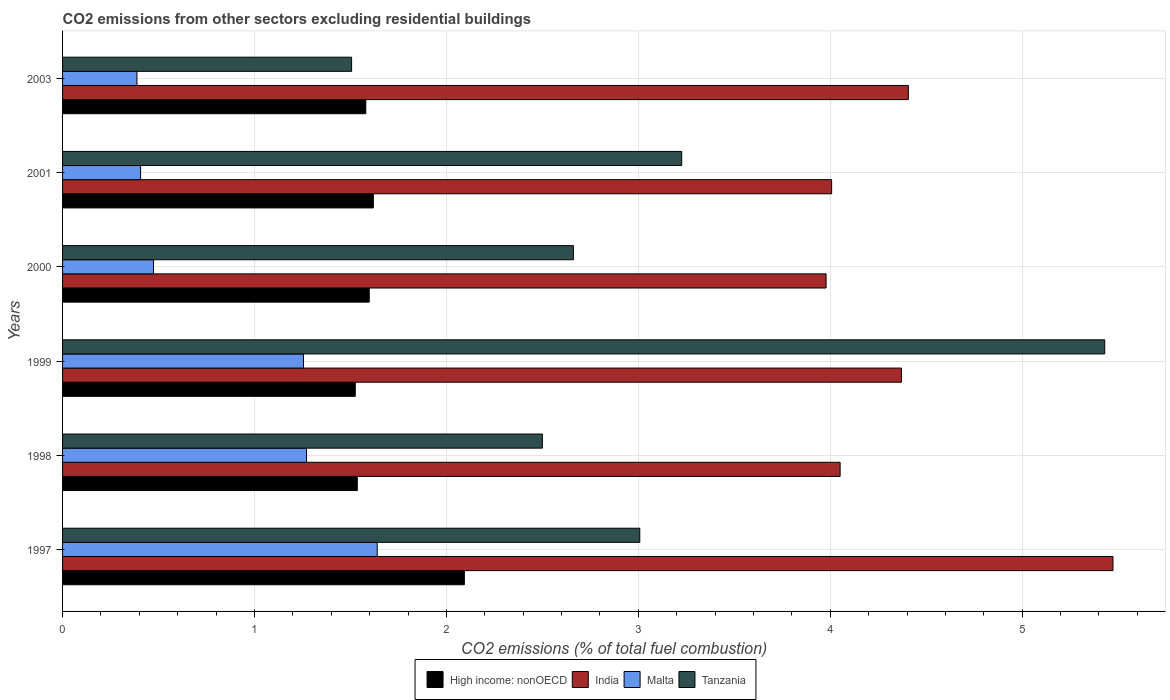How many bars are there on the 5th tick from the top?
Your answer should be very brief. 4. What is the label of the 1st group of bars from the top?
Provide a short and direct response. 2003. What is the total CO2 emitted in Tanzania in 2003?
Ensure brevity in your answer.  1.51. Across all years, what is the maximum total CO2 emitted in India?
Ensure brevity in your answer.  5.47. Across all years, what is the minimum total CO2 emitted in Malta?
Ensure brevity in your answer.  0.39. What is the total total CO2 emitted in India in the graph?
Offer a very short reply. 26.29. What is the difference between the total CO2 emitted in High income: nonOECD in 1997 and that in 2000?
Keep it short and to the point. 0.5. What is the difference between the total CO2 emitted in High income: nonOECD in 1999 and the total CO2 emitted in Tanzania in 2003?
Your response must be concise. 0.02. What is the average total CO2 emitted in India per year?
Keep it short and to the point. 4.38. In the year 1998, what is the difference between the total CO2 emitted in Malta and total CO2 emitted in India?
Provide a short and direct response. -2.78. In how many years, is the total CO2 emitted in High income: nonOECD greater than 3.4 ?
Make the answer very short. 0. What is the ratio of the total CO2 emitted in High income: nonOECD in 2000 to that in 2001?
Your answer should be compact. 0.99. Is the total CO2 emitted in Malta in 2001 less than that in 2003?
Offer a terse response. No. Is the difference between the total CO2 emitted in Malta in 2000 and 2001 greater than the difference between the total CO2 emitted in India in 2000 and 2001?
Provide a succinct answer. Yes. What is the difference between the highest and the second highest total CO2 emitted in Malta?
Keep it short and to the point. 0.37. What is the difference between the highest and the lowest total CO2 emitted in India?
Provide a succinct answer. 1.49. In how many years, is the total CO2 emitted in High income: nonOECD greater than the average total CO2 emitted in High income: nonOECD taken over all years?
Provide a short and direct response. 1. Is the sum of the total CO2 emitted in India in 1997 and 2003 greater than the maximum total CO2 emitted in Tanzania across all years?
Give a very brief answer. Yes. Is it the case that in every year, the sum of the total CO2 emitted in Malta and total CO2 emitted in High income: nonOECD is greater than the sum of total CO2 emitted in India and total CO2 emitted in Tanzania?
Your answer should be compact. No. What does the 4th bar from the top in 2003 represents?
Provide a short and direct response. High income: nonOECD. What does the 3rd bar from the bottom in 2003 represents?
Your response must be concise. Malta. Are all the bars in the graph horizontal?
Provide a short and direct response. Yes. How many years are there in the graph?
Give a very brief answer. 6. What is the difference between two consecutive major ticks on the X-axis?
Your answer should be very brief. 1. Are the values on the major ticks of X-axis written in scientific E-notation?
Ensure brevity in your answer.  No. Does the graph contain any zero values?
Give a very brief answer. No. How many legend labels are there?
Make the answer very short. 4. How are the legend labels stacked?
Your answer should be very brief. Horizontal. What is the title of the graph?
Your answer should be very brief. CO2 emissions from other sectors excluding residential buildings. What is the label or title of the X-axis?
Keep it short and to the point. CO2 emissions (% of total fuel combustion). What is the label or title of the Y-axis?
Your answer should be compact. Years. What is the CO2 emissions (% of total fuel combustion) of High income: nonOECD in 1997?
Keep it short and to the point. 2.09. What is the CO2 emissions (% of total fuel combustion) in India in 1997?
Ensure brevity in your answer.  5.47. What is the CO2 emissions (% of total fuel combustion) in Malta in 1997?
Make the answer very short. 1.64. What is the CO2 emissions (% of total fuel combustion) in Tanzania in 1997?
Your answer should be very brief. 3.01. What is the CO2 emissions (% of total fuel combustion) in High income: nonOECD in 1998?
Your response must be concise. 1.54. What is the CO2 emissions (% of total fuel combustion) of India in 1998?
Give a very brief answer. 4.05. What is the CO2 emissions (% of total fuel combustion) of Malta in 1998?
Ensure brevity in your answer.  1.27. What is the CO2 emissions (% of total fuel combustion) of High income: nonOECD in 1999?
Give a very brief answer. 1.53. What is the CO2 emissions (% of total fuel combustion) in India in 1999?
Keep it short and to the point. 4.37. What is the CO2 emissions (% of total fuel combustion) in Malta in 1999?
Keep it short and to the point. 1.26. What is the CO2 emissions (% of total fuel combustion) in Tanzania in 1999?
Offer a terse response. 5.43. What is the CO2 emissions (% of total fuel combustion) in High income: nonOECD in 2000?
Provide a short and direct response. 1.6. What is the CO2 emissions (% of total fuel combustion) of India in 2000?
Make the answer very short. 3.98. What is the CO2 emissions (% of total fuel combustion) of Malta in 2000?
Give a very brief answer. 0.47. What is the CO2 emissions (% of total fuel combustion) of Tanzania in 2000?
Provide a short and direct response. 2.66. What is the CO2 emissions (% of total fuel combustion) of High income: nonOECD in 2001?
Your answer should be very brief. 1.62. What is the CO2 emissions (% of total fuel combustion) of India in 2001?
Offer a terse response. 4.01. What is the CO2 emissions (% of total fuel combustion) of Malta in 2001?
Provide a succinct answer. 0.41. What is the CO2 emissions (% of total fuel combustion) in Tanzania in 2001?
Your answer should be very brief. 3.23. What is the CO2 emissions (% of total fuel combustion) in High income: nonOECD in 2003?
Offer a terse response. 1.58. What is the CO2 emissions (% of total fuel combustion) of India in 2003?
Give a very brief answer. 4.41. What is the CO2 emissions (% of total fuel combustion) in Malta in 2003?
Provide a succinct answer. 0.39. What is the CO2 emissions (% of total fuel combustion) of Tanzania in 2003?
Provide a succinct answer. 1.51. Across all years, what is the maximum CO2 emissions (% of total fuel combustion) in High income: nonOECD?
Your answer should be very brief. 2.09. Across all years, what is the maximum CO2 emissions (% of total fuel combustion) in India?
Provide a short and direct response. 5.47. Across all years, what is the maximum CO2 emissions (% of total fuel combustion) of Malta?
Keep it short and to the point. 1.64. Across all years, what is the maximum CO2 emissions (% of total fuel combustion) of Tanzania?
Keep it short and to the point. 5.43. Across all years, what is the minimum CO2 emissions (% of total fuel combustion) of High income: nonOECD?
Your response must be concise. 1.53. Across all years, what is the minimum CO2 emissions (% of total fuel combustion) in India?
Your answer should be compact. 3.98. Across all years, what is the minimum CO2 emissions (% of total fuel combustion) of Malta?
Your answer should be very brief. 0.39. Across all years, what is the minimum CO2 emissions (% of total fuel combustion) of Tanzania?
Provide a short and direct response. 1.51. What is the total CO2 emissions (% of total fuel combustion) of High income: nonOECD in the graph?
Your response must be concise. 9.95. What is the total CO2 emissions (% of total fuel combustion) in India in the graph?
Your answer should be very brief. 26.29. What is the total CO2 emissions (% of total fuel combustion) in Malta in the graph?
Provide a succinct answer. 5.43. What is the total CO2 emissions (% of total fuel combustion) of Tanzania in the graph?
Provide a succinct answer. 18.33. What is the difference between the CO2 emissions (% of total fuel combustion) in High income: nonOECD in 1997 and that in 1998?
Give a very brief answer. 0.56. What is the difference between the CO2 emissions (% of total fuel combustion) of India in 1997 and that in 1998?
Your answer should be compact. 1.42. What is the difference between the CO2 emissions (% of total fuel combustion) in Malta in 1997 and that in 1998?
Offer a terse response. 0.37. What is the difference between the CO2 emissions (% of total fuel combustion) of Tanzania in 1997 and that in 1998?
Your answer should be compact. 0.51. What is the difference between the CO2 emissions (% of total fuel combustion) of High income: nonOECD in 1997 and that in 1999?
Provide a succinct answer. 0.57. What is the difference between the CO2 emissions (% of total fuel combustion) in India in 1997 and that in 1999?
Make the answer very short. 1.1. What is the difference between the CO2 emissions (% of total fuel combustion) of Malta in 1997 and that in 1999?
Keep it short and to the point. 0.38. What is the difference between the CO2 emissions (% of total fuel combustion) in Tanzania in 1997 and that in 1999?
Keep it short and to the point. -2.42. What is the difference between the CO2 emissions (% of total fuel combustion) in High income: nonOECD in 1997 and that in 2000?
Keep it short and to the point. 0.5. What is the difference between the CO2 emissions (% of total fuel combustion) in India in 1997 and that in 2000?
Ensure brevity in your answer.  1.49. What is the difference between the CO2 emissions (% of total fuel combustion) of Malta in 1997 and that in 2000?
Ensure brevity in your answer.  1.17. What is the difference between the CO2 emissions (% of total fuel combustion) in Tanzania in 1997 and that in 2000?
Your answer should be compact. 0.35. What is the difference between the CO2 emissions (% of total fuel combustion) of High income: nonOECD in 1997 and that in 2001?
Your response must be concise. 0.47. What is the difference between the CO2 emissions (% of total fuel combustion) of India in 1997 and that in 2001?
Give a very brief answer. 1.47. What is the difference between the CO2 emissions (% of total fuel combustion) in Malta in 1997 and that in 2001?
Offer a terse response. 1.23. What is the difference between the CO2 emissions (% of total fuel combustion) of Tanzania in 1997 and that in 2001?
Offer a very short reply. -0.22. What is the difference between the CO2 emissions (% of total fuel combustion) in High income: nonOECD in 1997 and that in 2003?
Provide a short and direct response. 0.51. What is the difference between the CO2 emissions (% of total fuel combustion) of India in 1997 and that in 2003?
Keep it short and to the point. 1.07. What is the difference between the CO2 emissions (% of total fuel combustion) in Malta in 1997 and that in 2003?
Your answer should be compact. 1.25. What is the difference between the CO2 emissions (% of total fuel combustion) in Tanzania in 1997 and that in 2003?
Your response must be concise. 1.5. What is the difference between the CO2 emissions (% of total fuel combustion) of High income: nonOECD in 1998 and that in 1999?
Your response must be concise. 0.01. What is the difference between the CO2 emissions (% of total fuel combustion) in India in 1998 and that in 1999?
Your response must be concise. -0.32. What is the difference between the CO2 emissions (% of total fuel combustion) in Malta in 1998 and that in 1999?
Your answer should be very brief. 0.02. What is the difference between the CO2 emissions (% of total fuel combustion) in Tanzania in 1998 and that in 1999?
Keep it short and to the point. -2.93. What is the difference between the CO2 emissions (% of total fuel combustion) in High income: nonOECD in 1998 and that in 2000?
Provide a short and direct response. -0.06. What is the difference between the CO2 emissions (% of total fuel combustion) of India in 1998 and that in 2000?
Provide a succinct answer. 0.07. What is the difference between the CO2 emissions (% of total fuel combustion) in Malta in 1998 and that in 2000?
Your response must be concise. 0.8. What is the difference between the CO2 emissions (% of total fuel combustion) in Tanzania in 1998 and that in 2000?
Your response must be concise. -0.16. What is the difference between the CO2 emissions (% of total fuel combustion) of High income: nonOECD in 1998 and that in 2001?
Ensure brevity in your answer.  -0.08. What is the difference between the CO2 emissions (% of total fuel combustion) of India in 1998 and that in 2001?
Provide a short and direct response. 0.04. What is the difference between the CO2 emissions (% of total fuel combustion) of Malta in 1998 and that in 2001?
Give a very brief answer. 0.86. What is the difference between the CO2 emissions (% of total fuel combustion) of Tanzania in 1998 and that in 2001?
Keep it short and to the point. -0.73. What is the difference between the CO2 emissions (% of total fuel combustion) of High income: nonOECD in 1998 and that in 2003?
Offer a very short reply. -0.04. What is the difference between the CO2 emissions (% of total fuel combustion) in India in 1998 and that in 2003?
Provide a succinct answer. -0.36. What is the difference between the CO2 emissions (% of total fuel combustion) of Malta in 1998 and that in 2003?
Your response must be concise. 0.88. What is the difference between the CO2 emissions (% of total fuel combustion) of Tanzania in 1998 and that in 2003?
Offer a very short reply. 0.99. What is the difference between the CO2 emissions (% of total fuel combustion) in High income: nonOECD in 1999 and that in 2000?
Ensure brevity in your answer.  -0.07. What is the difference between the CO2 emissions (% of total fuel combustion) in India in 1999 and that in 2000?
Your response must be concise. 0.39. What is the difference between the CO2 emissions (% of total fuel combustion) of Malta in 1999 and that in 2000?
Ensure brevity in your answer.  0.78. What is the difference between the CO2 emissions (% of total fuel combustion) in Tanzania in 1999 and that in 2000?
Offer a terse response. 2.77. What is the difference between the CO2 emissions (% of total fuel combustion) in High income: nonOECD in 1999 and that in 2001?
Offer a very short reply. -0.09. What is the difference between the CO2 emissions (% of total fuel combustion) in India in 1999 and that in 2001?
Provide a short and direct response. 0.36. What is the difference between the CO2 emissions (% of total fuel combustion) in Malta in 1999 and that in 2001?
Keep it short and to the point. 0.85. What is the difference between the CO2 emissions (% of total fuel combustion) in Tanzania in 1999 and that in 2001?
Offer a very short reply. 2.2. What is the difference between the CO2 emissions (% of total fuel combustion) in High income: nonOECD in 1999 and that in 2003?
Give a very brief answer. -0.05. What is the difference between the CO2 emissions (% of total fuel combustion) in India in 1999 and that in 2003?
Keep it short and to the point. -0.04. What is the difference between the CO2 emissions (% of total fuel combustion) in Malta in 1999 and that in 2003?
Provide a succinct answer. 0.87. What is the difference between the CO2 emissions (% of total fuel combustion) in Tanzania in 1999 and that in 2003?
Your answer should be compact. 3.92. What is the difference between the CO2 emissions (% of total fuel combustion) of High income: nonOECD in 2000 and that in 2001?
Provide a succinct answer. -0.02. What is the difference between the CO2 emissions (% of total fuel combustion) in India in 2000 and that in 2001?
Provide a short and direct response. -0.03. What is the difference between the CO2 emissions (% of total fuel combustion) in Malta in 2000 and that in 2001?
Your answer should be very brief. 0.07. What is the difference between the CO2 emissions (% of total fuel combustion) of Tanzania in 2000 and that in 2001?
Ensure brevity in your answer.  -0.56. What is the difference between the CO2 emissions (% of total fuel combustion) in High income: nonOECD in 2000 and that in 2003?
Ensure brevity in your answer.  0.02. What is the difference between the CO2 emissions (% of total fuel combustion) in India in 2000 and that in 2003?
Offer a terse response. -0.43. What is the difference between the CO2 emissions (% of total fuel combustion) of Malta in 2000 and that in 2003?
Offer a terse response. 0.09. What is the difference between the CO2 emissions (% of total fuel combustion) in Tanzania in 2000 and that in 2003?
Make the answer very short. 1.16. What is the difference between the CO2 emissions (% of total fuel combustion) of High income: nonOECD in 2001 and that in 2003?
Provide a succinct answer. 0.04. What is the difference between the CO2 emissions (% of total fuel combustion) in India in 2001 and that in 2003?
Provide a succinct answer. -0.4. What is the difference between the CO2 emissions (% of total fuel combustion) in Malta in 2001 and that in 2003?
Ensure brevity in your answer.  0.02. What is the difference between the CO2 emissions (% of total fuel combustion) in Tanzania in 2001 and that in 2003?
Your answer should be very brief. 1.72. What is the difference between the CO2 emissions (% of total fuel combustion) in High income: nonOECD in 1997 and the CO2 emissions (% of total fuel combustion) in India in 1998?
Offer a very short reply. -1.96. What is the difference between the CO2 emissions (% of total fuel combustion) of High income: nonOECD in 1997 and the CO2 emissions (% of total fuel combustion) of Malta in 1998?
Your answer should be very brief. 0.82. What is the difference between the CO2 emissions (% of total fuel combustion) of High income: nonOECD in 1997 and the CO2 emissions (% of total fuel combustion) of Tanzania in 1998?
Offer a very short reply. -0.41. What is the difference between the CO2 emissions (% of total fuel combustion) in India in 1997 and the CO2 emissions (% of total fuel combustion) in Malta in 1998?
Offer a very short reply. 4.2. What is the difference between the CO2 emissions (% of total fuel combustion) of India in 1997 and the CO2 emissions (% of total fuel combustion) of Tanzania in 1998?
Offer a terse response. 2.97. What is the difference between the CO2 emissions (% of total fuel combustion) of Malta in 1997 and the CO2 emissions (% of total fuel combustion) of Tanzania in 1998?
Offer a terse response. -0.86. What is the difference between the CO2 emissions (% of total fuel combustion) in High income: nonOECD in 1997 and the CO2 emissions (% of total fuel combustion) in India in 1999?
Ensure brevity in your answer.  -2.28. What is the difference between the CO2 emissions (% of total fuel combustion) in High income: nonOECD in 1997 and the CO2 emissions (% of total fuel combustion) in Malta in 1999?
Give a very brief answer. 0.84. What is the difference between the CO2 emissions (% of total fuel combustion) of High income: nonOECD in 1997 and the CO2 emissions (% of total fuel combustion) of Tanzania in 1999?
Your answer should be very brief. -3.34. What is the difference between the CO2 emissions (% of total fuel combustion) in India in 1997 and the CO2 emissions (% of total fuel combustion) in Malta in 1999?
Keep it short and to the point. 4.22. What is the difference between the CO2 emissions (% of total fuel combustion) of India in 1997 and the CO2 emissions (% of total fuel combustion) of Tanzania in 1999?
Keep it short and to the point. 0.04. What is the difference between the CO2 emissions (% of total fuel combustion) of Malta in 1997 and the CO2 emissions (% of total fuel combustion) of Tanzania in 1999?
Keep it short and to the point. -3.79. What is the difference between the CO2 emissions (% of total fuel combustion) in High income: nonOECD in 1997 and the CO2 emissions (% of total fuel combustion) in India in 2000?
Keep it short and to the point. -1.88. What is the difference between the CO2 emissions (% of total fuel combustion) in High income: nonOECD in 1997 and the CO2 emissions (% of total fuel combustion) in Malta in 2000?
Your response must be concise. 1.62. What is the difference between the CO2 emissions (% of total fuel combustion) of High income: nonOECD in 1997 and the CO2 emissions (% of total fuel combustion) of Tanzania in 2000?
Provide a short and direct response. -0.57. What is the difference between the CO2 emissions (% of total fuel combustion) in India in 1997 and the CO2 emissions (% of total fuel combustion) in Malta in 2000?
Make the answer very short. 5. What is the difference between the CO2 emissions (% of total fuel combustion) in India in 1997 and the CO2 emissions (% of total fuel combustion) in Tanzania in 2000?
Ensure brevity in your answer.  2.81. What is the difference between the CO2 emissions (% of total fuel combustion) of Malta in 1997 and the CO2 emissions (% of total fuel combustion) of Tanzania in 2000?
Provide a short and direct response. -1.02. What is the difference between the CO2 emissions (% of total fuel combustion) in High income: nonOECD in 1997 and the CO2 emissions (% of total fuel combustion) in India in 2001?
Your answer should be very brief. -1.91. What is the difference between the CO2 emissions (% of total fuel combustion) of High income: nonOECD in 1997 and the CO2 emissions (% of total fuel combustion) of Malta in 2001?
Provide a short and direct response. 1.69. What is the difference between the CO2 emissions (% of total fuel combustion) of High income: nonOECD in 1997 and the CO2 emissions (% of total fuel combustion) of Tanzania in 2001?
Ensure brevity in your answer.  -1.13. What is the difference between the CO2 emissions (% of total fuel combustion) in India in 1997 and the CO2 emissions (% of total fuel combustion) in Malta in 2001?
Your response must be concise. 5.07. What is the difference between the CO2 emissions (% of total fuel combustion) of India in 1997 and the CO2 emissions (% of total fuel combustion) of Tanzania in 2001?
Make the answer very short. 2.25. What is the difference between the CO2 emissions (% of total fuel combustion) of Malta in 1997 and the CO2 emissions (% of total fuel combustion) of Tanzania in 2001?
Ensure brevity in your answer.  -1.59. What is the difference between the CO2 emissions (% of total fuel combustion) of High income: nonOECD in 1997 and the CO2 emissions (% of total fuel combustion) of India in 2003?
Offer a terse response. -2.31. What is the difference between the CO2 emissions (% of total fuel combustion) in High income: nonOECD in 1997 and the CO2 emissions (% of total fuel combustion) in Malta in 2003?
Give a very brief answer. 1.71. What is the difference between the CO2 emissions (% of total fuel combustion) in High income: nonOECD in 1997 and the CO2 emissions (% of total fuel combustion) in Tanzania in 2003?
Your answer should be very brief. 0.59. What is the difference between the CO2 emissions (% of total fuel combustion) of India in 1997 and the CO2 emissions (% of total fuel combustion) of Malta in 2003?
Your answer should be very brief. 5.09. What is the difference between the CO2 emissions (% of total fuel combustion) in India in 1997 and the CO2 emissions (% of total fuel combustion) in Tanzania in 2003?
Your answer should be very brief. 3.97. What is the difference between the CO2 emissions (% of total fuel combustion) of Malta in 1997 and the CO2 emissions (% of total fuel combustion) of Tanzania in 2003?
Make the answer very short. 0.13. What is the difference between the CO2 emissions (% of total fuel combustion) of High income: nonOECD in 1998 and the CO2 emissions (% of total fuel combustion) of India in 1999?
Offer a very short reply. -2.84. What is the difference between the CO2 emissions (% of total fuel combustion) in High income: nonOECD in 1998 and the CO2 emissions (% of total fuel combustion) in Malta in 1999?
Ensure brevity in your answer.  0.28. What is the difference between the CO2 emissions (% of total fuel combustion) of High income: nonOECD in 1998 and the CO2 emissions (% of total fuel combustion) of Tanzania in 1999?
Offer a terse response. -3.89. What is the difference between the CO2 emissions (% of total fuel combustion) of India in 1998 and the CO2 emissions (% of total fuel combustion) of Malta in 1999?
Your response must be concise. 2.8. What is the difference between the CO2 emissions (% of total fuel combustion) in India in 1998 and the CO2 emissions (% of total fuel combustion) in Tanzania in 1999?
Keep it short and to the point. -1.38. What is the difference between the CO2 emissions (% of total fuel combustion) of Malta in 1998 and the CO2 emissions (% of total fuel combustion) of Tanzania in 1999?
Offer a terse response. -4.16. What is the difference between the CO2 emissions (% of total fuel combustion) of High income: nonOECD in 1998 and the CO2 emissions (% of total fuel combustion) of India in 2000?
Offer a terse response. -2.44. What is the difference between the CO2 emissions (% of total fuel combustion) of High income: nonOECD in 1998 and the CO2 emissions (% of total fuel combustion) of Malta in 2000?
Provide a short and direct response. 1.06. What is the difference between the CO2 emissions (% of total fuel combustion) of High income: nonOECD in 1998 and the CO2 emissions (% of total fuel combustion) of Tanzania in 2000?
Your answer should be very brief. -1.13. What is the difference between the CO2 emissions (% of total fuel combustion) in India in 1998 and the CO2 emissions (% of total fuel combustion) in Malta in 2000?
Provide a succinct answer. 3.58. What is the difference between the CO2 emissions (% of total fuel combustion) in India in 1998 and the CO2 emissions (% of total fuel combustion) in Tanzania in 2000?
Keep it short and to the point. 1.39. What is the difference between the CO2 emissions (% of total fuel combustion) of Malta in 1998 and the CO2 emissions (% of total fuel combustion) of Tanzania in 2000?
Provide a short and direct response. -1.39. What is the difference between the CO2 emissions (% of total fuel combustion) in High income: nonOECD in 1998 and the CO2 emissions (% of total fuel combustion) in India in 2001?
Provide a succinct answer. -2.47. What is the difference between the CO2 emissions (% of total fuel combustion) of High income: nonOECD in 1998 and the CO2 emissions (% of total fuel combustion) of Malta in 2001?
Your response must be concise. 1.13. What is the difference between the CO2 emissions (% of total fuel combustion) in High income: nonOECD in 1998 and the CO2 emissions (% of total fuel combustion) in Tanzania in 2001?
Ensure brevity in your answer.  -1.69. What is the difference between the CO2 emissions (% of total fuel combustion) in India in 1998 and the CO2 emissions (% of total fuel combustion) in Malta in 2001?
Ensure brevity in your answer.  3.64. What is the difference between the CO2 emissions (% of total fuel combustion) of India in 1998 and the CO2 emissions (% of total fuel combustion) of Tanzania in 2001?
Your answer should be compact. 0.83. What is the difference between the CO2 emissions (% of total fuel combustion) in Malta in 1998 and the CO2 emissions (% of total fuel combustion) in Tanzania in 2001?
Your answer should be compact. -1.95. What is the difference between the CO2 emissions (% of total fuel combustion) in High income: nonOECD in 1998 and the CO2 emissions (% of total fuel combustion) in India in 2003?
Provide a succinct answer. -2.87. What is the difference between the CO2 emissions (% of total fuel combustion) of High income: nonOECD in 1998 and the CO2 emissions (% of total fuel combustion) of Malta in 2003?
Offer a terse response. 1.15. What is the difference between the CO2 emissions (% of total fuel combustion) in High income: nonOECD in 1998 and the CO2 emissions (% of total fuel combustion) in Tanzania in 2003?
Give a very brief answer. 0.03. What is the difference between the CO2 emissions (% of total fuel combustion) in India in 1998 and the CO2 emissions (% of total fuel combustion) in Malta in 2003?
Provide a short and direct response. 3.66. What is the difference between the CO2 emissions (% of total fuel combustion) of India in 1998 and the CO2 emissions (% of total fuel combustion) of Tanzania in 2003?
Give a very brief answer. 2.55. What is the difference between the CO2 emissions (% of total fuel combustion) of Malta in 1998 and the CO2 emissions (% of total fuel combustion) of Tanzania in 2003?
Provide a succinct answer. -0.23. What is the difference between the CO2 emissions (% of total fuel combustion) of High income: nonOECD in 1999 and the CO2 emissions (% of total fuel combustion) of India in 2000?
Your answer should be very brief. -2.45. What is the difference between the CO2 emissions (% of total fuel combustion) of High income: nonOECD in 1999 and the CO2 emissions (% of total fuel combustion) of Malta in 2000?
Give a very brief answer. 1.05. What is the difference between the CO2 emissions (% of total fuel combustion) in High income: nonOECD in 1999 and the CO2 emissions (% of total fuel combustion) in Tanzania in 2000?
Provide a short and direct response. -1.14. What is the difference between the CO2 emissions (% of total fuel combustion) in India in 1999 and the CO2 emissions (% of total fuel combustion) in Malta in 2000?
Provide a succinct answer. 3.9. What is the difference between the CO2 emissions (% of total fuel combustion) in India in 1999 and the CO2 emissions (% of total fuel combustion) in Tanzania in 2000?
Make the answer very short. 1.71. What is the difference between the CO2 emissions (% of total fuel combustion) of Malta in 1999 and the CO2 emissions (% of total fuel combustion) of Tanzania in 2000?
Make the answer very short. -1.41. What is the difference between the CO2 emissions (% of total fuel combustion) in High income: nonOECD in 1999 and the CO2 emissions (% of total fuel combustion) in India in 2001?
Offer a very short reply. -2.48. What is the difference between the CO2 emissions (% of total fuel combustion) in High income: nonOECD in 1999 and the CO2 emissions (% of total fuel combustion) in Malta in 2001?
Your response must be concise. 1.12. What is the difference between the CO2 emissions (% of total fuel combustion) in High income: nonOECD in 1999 and the CO2 emissions (% of total fuel combustion) in Tanzania in 2001?
Give a very brief answer. -1.7. What is the difference between the CO2 emissions (% of total fuel combustion) in India in 1999 and the CO2 emissions (% of total fuel combustion) in Malta in 2001?
Make the answer very short. 3.96. What is the difference between the CO2 emissions (% of total fuel combustion) in India in 1999 and the CO2 emissions (% of total fuel combustion) in Tanzania in 2001?
Provide a succinct answer. 1.15. What is the difference between the CO2 emissions (% of total fuel combustion) in Malta in 1999 and the CO2 emissions (% of total fuel combustion) in Tanzania in 2001?
Make the answer very short. -1.97. What is the difference between the CO2 emissions (% of total fuel combustion) of High income: nonOECD in 1999 and the CO2 emissions (% of total fuel combustion) of India in 2003?
Ensure brevity in your answer.  -2.88. What is the difference between the CO2 emissions (% of total fuel combustion) of High income: nonOECD in 1999 and the CO2 emissions (% of total fuel combustion) of Malta in 2003?
Make the answer very short. 1.14. What is the difference between the CO2 emissions (% of total fuel combustion) in High income: nonOECD in 1999 and the CO2 emissions (% of total fuel combustion) in Tanzania in 2003?
Give a very brief answer. 0.02. What is the difference between the CO2 emissions (% of total fuel combustion) in India in 1999 and the CO2 emissions (% of total fuel combustion) in Malta in 2003?
Make the answer very short. 3.98. What is the difference between the CO2 emissions (% of total fuel combustion) in India in 1999 and the CO2 emissions (% of total fuel combustion) in Tanzania in 2003?
Provide a succinct answer. 2.87. What is the difference between the CO2 emissions (% of total fuel combustion) of Malta in 1999 and the CO2 emissions (% of total fuel combustion) of Tanzania in 2003?
Give a very brief answer. -0.25. What is the difference between the CO2 emissions (% of total fuel combustion) in High income: nonOECD in 2000 and the CO2 emissions (% of total fuel combustion) in India in 2001?
Offer a terse response. -2.41. What is the difference between the CO2 emissions (% of total fuel combustion) in High income: nonOECD in 2000 and the CO2 emissions (% of total fuel combustion) in Malta in 2001?
Your answer should be very brief. 1.19. What is the difference between the CO2 emissions (% of total fuel combustion) of High income: nonOECD in 2000 and the CO2 emissions (% of total fuel combustion) of Tanzania in 2001?
Provide a succinct answer. -1.63. What is the difference between the CO2 emissions (% of total fuel combustion) in India in 2000 and the CO2 emissions (% of total fuel combustion) in Malta in 2001?
Offer a very short reply. 3.57. What is the difference between the CO2 emissions (% of total fuel combustion) of India in 2000 and the CO2 emissions (% of total fuel combustion) of Tanzania in 2001?
Your answer should be compact. 0.75. What is the difference between the CO2 emissions (% of total fuel combustion) of Malta in 2000 and the CO2 emissions (% of total fuel combustion) of Tanzania in 2001?
Provide a succinct answer. -2.75. What is the difference between the CO2 emissions (% of total fuel combustion) of High income: nonOECD in 2000 and the CO2 emissions (% of total fuel combustion) of India in 2003?
Keep it short and to the point. -2.81. What is the difference between the CO2 emissions (% of total fuel combustion) in High income: nonOECD in 2000 and the CO2 emissions (% of total fuel combustion) in Malta in 2003?
Offer a very short reply. 1.21. What is the difference between the CO2 emissions (% of total fuel combustion) in High income: nonOECD in 2000 and the CO2 emissions (% of total fuel combustion) in Tanzania in 2003?
Your answer should be compact. 0.09. What is the difference between the CO2 emissions (% of total fuel combustion) of India in 2000 and the CO2 emissions (% of total fuel combustion) of Malta in 2003?
Your answer should be very brief. 3.59. What is the difference between the CO2 emissions (% of total fuel combustion) in India in 2000 and the CO2 emissions (% of total fuel combustion) in Tanzania in 2003?
Keep it short and to the point. 2.47. What is the difference between the CO2 emissions (% of total fuel combustion) of Malta in 2000 and the CO2 emissions (% of total fuel combustion) of Tanzania in 2003?
Ensure brevity in your answer.  -1.03. What is the difference between the CO2 emissions (% of total fuel combustion) in High income: nonOECD in 2001 and the CO2 emissions (% of total fuel combustion) in India in 2003?
Offer a terse response. -2.79. What is the difference between the CO2 emissions (% of total fuel combustion) in High income: nonOECD in 2001 and the CO2 emissions (% of total fuel combustion) in Malta in 2003?
Ensure brevity in your answer.  1.23. What is the difference between the CO2 emissions (% of total fuel combustion) in High income: nonOECD in 2001 and the CO2 emissions (% of total fuel combustion) in Tanzania in 2003?
Ensure brevity in your answer.  0.11. What is the difference between the CO2 emissions (% of total fuel combustion) of India in 2001 and the CO2 emissions (% of total fuel combustion) of Malta in 2003?
Your answer should be very brief. 3.62. What is the difference between the CO2 emissions (% of total fuel combustion) in India in 2001 and the CO2 emissions (% of total fuel combustion) in Tanzania in 2003?
Your answer should be very brief. 2.5. What is the difference between the CO2 emissions (% of total fuel combustion) in Malta in 2001 and the CO2 emissions (% of total fuel combustion) in Tanzania in 2003?
Keep it short and to the point. -1.1. What is the average CO2 emissions (% of total fuel combustion) of High income: nonOECD per year?
Ensure brevity in your answer.  1.66. What is the average CO2 emissions (% of total fuel combustion) in India per year?
Your answer should be compact. 4.38. What is the average CO2 emissions (% of total fuel combustion) of Malta per year?
Ensure brevity in your answer.  0.91. What is the average CO2 emissions (% of total fuel combustion) of Tanzania per year?
Offer a very short reply. 3.06. In the year 1997, what is the difference between the CO2 emissions (% of total fuel combustion) of High income: nonOECD and CO2 emissions (% of total fuel combustion) of India?
Ensure brevity in your answer.  -3.38. In the year 1997, what is the difference between the CO2 emissions (% of total fuel combustion) in High income: nonOECD and CO2 emissions (% of total fuel combustion) in Malta?
Ensure brevity in your answer.  0.45. In the year 1997, what is the difference between the CO2 emissions (% of total fuel combustion) in High income: nonOECD and CO2 emissions (% of total fuel combustion) in Tanzania?
Your answer should be very brief. -0.91. In the year 1997, what is the difference between the CO2 emissions (% of total fuel combustion) of India and CO2 emissions (% of total fuel combustion) of Malta?
Keep it short and to the point. 3.83. In the year 1997, what is the difference between the CO2 emissions (% of total fuel combustion) in India and CO2 emissions (% of total fuel combustion) in Tanzania?
Give a very brief answer. 2.47. In the year 1997, what is the difference between the CO2 emissions (% of total fuel combustion) of Malta and CO2 emissions (% of total fuel combustion) of Tanzania?
Ensure brevity in your answer.  -1.37. In the year 1998, what is the difference between the CO2 emissions (% of total fuel combustion) of High income: nonOECD and CO2 emissions (% of total fuel combustion) of India?
Your answer should be very brief. -2.52. In the year 1998, what is the difference between the CO2 emissions (% of total fuel combustion) in High income: nonOECD and CO2 emissions (% of total fuel combustion) in Malta?
Your answer should be very brief. 0.26. In the year 1998, what is the difference between the CO2 emissions (% of total fuel combustion) of High income: nonOECD and CO2 emissions (% of total fuel combustion) of Tanzania?
Offer a terse response. -0.96. In the year 1998, what is the difference between the CO2 emissions (% of total fuel combustion) of India and CO2 emissions (% of total fuel combustion) of Malta?
Your answer should be compact. 2.78. In the year 1998, what is the difference between the CO2 emissions (% of total fuel combustion) of India and CO2 emissions (% of total fuel combustion) of Tanzania?
Provide a short and direct response. 1.55. In the year 1998, what is the difference between the CO2 emissions (% of total fuel combustion) in Malta and CO2 emissions (% of total fuel combustion) in Tanzania?
Give a very brief answer. -1.23. In the year 1999, what is the difference between the CO2 emissions (% of total fuel combustion) of High income: nonOECD and CO2 emissions (% of total fuel combustion) of India?
Your answer should be compact. -2.85. In the year 1999, what is the difference between the CO2 emissions (% of total fuel combustion) in High income: nonOECD and CO2 emissions (% of total fuel combustion) in Malta?
Provide a succinct answer. 0.27. In the year 1999, what is the difference between the CO2 emissions (% of total fuel combustion) of High income: nonOECD and CO2 emissions (% of total fuel combustion) of Tanzania?
Give a very brief answer. -3.9. In the year 1999, what is the difference between the CO2 emissions (% of total fuel combustion) in India and CO2 emissions (% of total fuel combustion) in Malta?
Your answer should be compact. 3.12. In the year 1999, what is the difference between the CO2 emissions (% of total fuel combustion) of India and CO2 emissions (% of total fuel combustion) of Tanzania?
Your answer should be compact. -1.06. In the year 1999, what is the difference between the CO2 emissions (% of total fuel combustion) in Malta and CO2 emissions (% of total fuel combustion) in Tanzania?
Ensure brevity in your answer.  -4.17. In the year 2000, what is the difference between the CO2 emissions (% of total fuel combustion) in High income: nonOECD and CO2 emissions (% of total fuel combustion) in India?
Give a very brief answer. -2.38. In the year 2000, what is the difference between the CO2 emissions (% of total fuel combustion) in High income: nonOECD and CO2 emissions (% of total fuel combustion) in Malta?
Your answer should be very brief. 1.12. In the year 2000, what is the difference between the CO2 emissions (% of total fuel combustion) in High income: nonOECD and CO2 emissions (% of total fuel combustion) in Tanzania?
Keep it short and to the point. -1.06. In the year 2000, what is the difference between the CO2 emissions (% of total fuel combustion) of India and CO2 emissions (% of total fuel combustion) of Malta?
Keep it short and to the point. 3.5. In the year 2000, what is the difference between the CO2 emissions (% of total fuel combustion) in India and CO2 emissions (% of total fuel combustion) in Tanzania?
Keep it short and to the point. 1.32. In the year 2000, what is the difference between the CO2 emissions (% of total fuel combustion) in Malta and CO2 emissions (% of total fuel combustion) in Tanzania?
Provide a succinct answer. -2.19. In the year 2001, what is the difference between the CO2 emissions (% of total fuel combustion) in High income: nonOECD and CO2 emissions (% of total fuel combustion) in India?
Provide a succinct answer. -2.39. In the year 2001, what is the difference between the CO2 emissions (% of total fuel combustion) of High income: nonOECD and CO2 emissions (% of total fuel combustion) of Malta?
Offer a very short reply. 1.21. In the year 2001, what is the difference between the CO2 emissions (% of total fuel combustion) in High income: nonOECD and CO2 emissions (% of total fuel combustion) in Tanzania?
Provide a succinct answer. -1.61. In the year 2001, what is the difference between the CO2 emissions (% of total fuel combustion) in India and CO2 emissions (% of total fuel combustion) in Malta?
Your answer should be very brief. 3.6. In the year 2001, what is the difference between the CO2 emissions (% of total fuel combustion) of India and CO2 emissions (% of total fuel combustion) of Tanzania?
Offer a terse response. 0.78. In the year 2001, what is the difference between the CO2 emissions (% of total fuel combustion) of Malta and CO2 emissions (% of total fuel combustion) of Tanzania?
Give a very brief answer. -2.82. In the year 2003, what is the difference between the CO2 emissions (% of total fuel combustion) in High income: nonOECD and CO2 emissions (% of total fuel combustion) in India?
Offer a terse response. -2.83. In the year 2003, what is the difference between the CO2 emissions (% of total fuel combustion) in High income: nonOECD and CO2 emissions (% of total fuel combustion) in Malta?
Ensure brevity in your answer.  1.19. In the year 2003, what is the difference between the CO2 emissions (% of total fuel combustion) in High income: nonOECD and CO2 emissions (% of total fuel combustion) in Tanzania?
Your answer should be very brief. 0.07. In the year 2003, what is the difference between the CO2 emissions (% of total fuel combustion) in India and CO2 emissions (% of total fuel combustion) in Malta?
Offer a terse response. 4.02. In the year 2003, what is the difference between the CO2 emissions (% of total fuel combustion) in India and CO2 emissions (% of total fuel combustion) in Tanzania?
Give a very brief answer. 2.9. In the year 2003, what is the difference between the CO2 emissions (% of total fuel combustion) of Malta and CO2 emissions (% of total fuel combustion) of Tanzania?
Provide a succinct answer. -1.12. What is the ratio of the CO2 emissions (% of total fuel combustion) in High income: nonOECD in 1997 to that in 1998?
Your answer should be compact. 1.36. What is the ratio of the CO2 emissions (% of total fuel combustion) of India in 1997 to that in 1998?
Your answer should be compact. 1.35. What is the ratio of the CO2 emissions (% of total fuel combustion) in Malta in 1997 to that in 1998?
Your answer should be compact. 1.29. What is the ratio of the CO2 emissions (% of total fuel combustion) of Tanzania in 1997 to that in 1998?
Offer a very short reply. 1.2. What is the ratio of the CO2 emissions (% of total fuel combustion) of High income: nonOECD in 1997 to that in 1999?
Offer a very short reply. 1.37. What is the ratio of the CO2 emissions (% of total fuel combustion) in India in 1997 to that in 1999?
Your answer should be very brief. 1.25. What is the ratio of the CO2 emissions (% of total fuel combustion) of Malta in 1997 to that in 1999?
Your answer should be compact. 1.31. What is the ratio of the CO2 emissions (% of total fuel combustion) in Tanzania in 1997 to that in 1999?
Give a very brief answer. 0.55. What is the ratio of the CO2 emissions (% of total fuel combustion) in High income: nonOECD in 1997 to that in 2000?
Keep it short and to the point. 1.31. What is the ratio of the CO2 emissions (% of total fuel combustion) of India in 1997 to that in 2000?
Keep it short and to the point. 1.38. What is the ratio of the CO2 emissions (% of total fuel combustion) in Malta in 1997 to that in 2000?
Give a very brief answer. 3.46. What is the ratio of the CO2 emissions (% of total fuel combustion) of Tanzania in 1997 to that in 2000?
Ensure brevity in your answer.  1.13. What is the ratio of the CO2 emissions (% of total fuel combustion) in High income: nonOECD in 1997 to that in 2001?
Offer a terse response. 1.29. What is the ratio of the CO2 emissions (% of total fuel combustion) of India in 1997 to that in 2001?
Provide a short and direct response. 1.37. What is the ratio of the CO2 emissions (% of total fuel combustion) of Malta in 1997 to that in 2001?
Keep it short and to the point. 4.03. What is the ratio of the CO2 emissions (% of total fuel combustion) in Tanzania in 1997 to that in 2001?
Your answer should be compact. 0.93. What is the ratio of the CO2 emissions (% of total fuel combustion) in High income: nonOECD in 1997 to that in 2003?
Provide a succinct answer. 1.32. What is the ratio of the CO2 emissions (% of total fuel combustion) of India in 1997 to that in 2003?
Give a very brief answer. 1.24. What is the ratio of the CO2 emissions (% of total fuel combustion) in Malta in 1997 to that in 2003?
Make the answer very short. 4.23. What is the ratio of the CO2 emissions (% of total fuel combustion) in Tanzania in 1997 to that in 2003?
Keep it short and to the point. 2. What is the ratio of the CO2 emissions (% of total fuel combustion) in India in 1998 to that in 1999?
Your answer should be compact. 0.93. What is the ratio of the CO2 emissions (% of total fuel combustion) of Malta in 1998 to that in 1999?
Offer a terse response. 1.01. What is the ratio of the CO2 emissions (% of total fuel combustion) of Tanzania in 1998 to that in 1999?
Keep it short and to the point. 0.46. What is the ratio of the CO2 emissions (% of total fuel combustion) in India in 1998 to that in 2000?
Provide a short and direct response. 1.02. What is the ratio of the CO2 emissions (% of total fuel combustion) of Malta in 1998 to that in 2000?
Provide a succinct answer. 2.68. What is the ratio of the CO2 emissions (% of total fuel combustion) of Tanzania in 1998 to that in 2000?
Make the answer very short. 0.94. What is the ratio of the CO2 emissions (% of total fuel combustion) of High income: nonOECD in 1998 to that in 2001?
Your answer should be compact. 0.95. What is the ratio of the CO2 emissions (% of total fuel combustion) of India in 1998 to that in 2001?
Your response must be concise. 1.01. What is the ratio of the CO2 emissions (% of total fuel combustion) in Malta in 1998 to that in 2001?
Offer a terse response. 3.13. What is the ratio of the CO2 emissions (% of total fuel combustion) of Tanzania in 1998 to that in 2001?
Give a very brief answer. 0.78. What is the ratio of the CO2 emissions (% of total fuel combustion) of High income: nonOECD in 1998 to that in 2003?
Your response must be concise. 0.97. What is the ratio of the CO2 emissions (% of total fuel combustion) in India in 1998 to that in 2003?
Ensure brevity in your answer.  0.92. What is the ratio of the CO2 emissions (% of total fuel combustion) in Malta in 1998 to that in 2003?
Make the answer very short. 3.28. What is the ratio of the CO2 emissions (% of total fuel combustion) of Tanzania in 1998 to that in 2003?
Provide a succinct answer. 1.66. What is the ratio of the CO2 emissions (% of total fuel combustion) in High income: nonOECD in 1999 to that in 2000?
Offer a very short reply. 0.95. What is the ratio of the CO2 emissions (% of total fuel combustion) in India in 1999 to that in 2000?
Your response must be concise. 1.1. What is the ratio of the CO2 emissions (% of total fuel combustion) of Malta in 1999 to that in 2000?
Your answer should be very brief. 2.65. What is the ratio of the CO2 emissions (% of total fuel combustion) in Tanzania in 1999 to that in 2000?
Give a very brief answer. 2.04. What is the ratio of the CO2 emissions (% of total fuel combustion) of High income: nonOECD in 1999 to that in 2001?
Keep it short and to the point. 0.94. What is the ratio of the CO2 emissions (% of total fuel combustion) of India in 1999 to that in 2001?
Give a very brief answer. 1.09. What is the ratio of the CO2 emissions (% of total fuel combustion) in Malta in 1999 to that in 2001?
Keep it short and to the point. 3.09. What is the ratio of the CO2 emissions (% of total fuel combustion) of Tanzania in 1999 to that in 2001?
Your response must be concise. 1.68. What is the ratio of the CO2 emissions (% of total fuel combustion) of High income: nonOECD in 1999 to that in 2003?
Keep it short and to the point. 0.97. What is the ratio of the CO2 emissions (% of total fuel combustion) of India in 1999 to that in 2003?
Provide a succinct answer. 0.99. What is the ratio of the CO2 emissions (% of total fuel combustion) in Malta in 1999 to that in 2003?
Ensure brevity in your answer.  3.24. What is the ratio of the CO2 emissions (% of total fuel combustion) of Tanzania in 1999 to that in 2003?
Keep it short and to the point. 3.61. What is the ratio of the CO2 emissions (% of total fuel combustion) of High income: nonOECD in 2000 to that in 2001?
Offer a very short reply. 0.99. What is the ratio of the CO2 emissions (% of total fuel combustion) of Malta in 2000 to that in 2001?
Provide a succinct answer. 1.17. What is the ratio of the CO2 emissions (% of total fuel combustion) in Tanzania in 2000 to that in 2001?
Provide a short and direct response. 0.83. What is the ratio of the CO2 emissions (% of total fuel combustion) in High income: nonOECD in 2000 to that in 2003?
Your answer should be very brief. 1.01. What is the ratio of the CO2 emissions (% of total fuel combustion) of India in 2000 to that in 2003?
Your answer should be very brief. 0.9. What is the ratio of the CO2 emissions (% of total fuel combustion) in Malta in 2000 to that in 2003?
Ensure brevity in your answer.  1.22. What is the ratio of the CO2 emissions (% of total fuel combustion) of Tanzania in 2000 to that in 2003?
Provide a short and direct response. 1.77. What is the ratio of the CO2 emissions (% of total fuel combustion) in High income: nonOECD in 2001 to that in 2003?
Give a very brief answer. 1.02. What is the ratio of the CO2 emissions (% of total fuel combustion) of India in 2001 to that in 2003?
Keep it short and to the point. 0.91. What is the ratio of the CO2 emissions (% of total fuel combustion) of Malta in 2001 to that in 2003?
Make the answer very short. 1.05. What is the ratio of the CO2 emissions (% of total fuel combustion) of Tanzania in 2001 to that in 2003?
Keep it short and to the point. 2.14. What is the difference between the highest and the second highest CO2 emissions (% of total fuel combustion) of High income: nonOECD?
Give a very brief answer. 0.47. What is the difference between the highest and the second highest CO2 emissions (% of total fuel combustion) in India?
Provide a short and direct response. 1.07. What is the difference between the highest and the second highest CO2 emissions (% of total fuel combustion) in Malta?
Keep it short and to the point. 0.37. What is the difference between the highest and the second highest CO2 emissions (% of total fuel combustion) in Tanzania?
Give a very brief answer. 2.2. What is the difference between the highest and the lowest CO2 emissions (% of total fuel combustion) in High income: nonOECD?
Your answer should be compact. 0.57. What is the difference between the highest and the lowest CO2 emissions (% of total fuel combustion) in India?
Your response must be concise. 1.49. What is the difference between the highest and the lowest CO2 emissions (% of total fuel combustion) in Malta?
Provide a succinct answer. 1.25. What is the difference between the highest and the lowest CO2 emissions (% of total fuel combustion) in Tanzania?
Your answer should be compact. 3.92. 